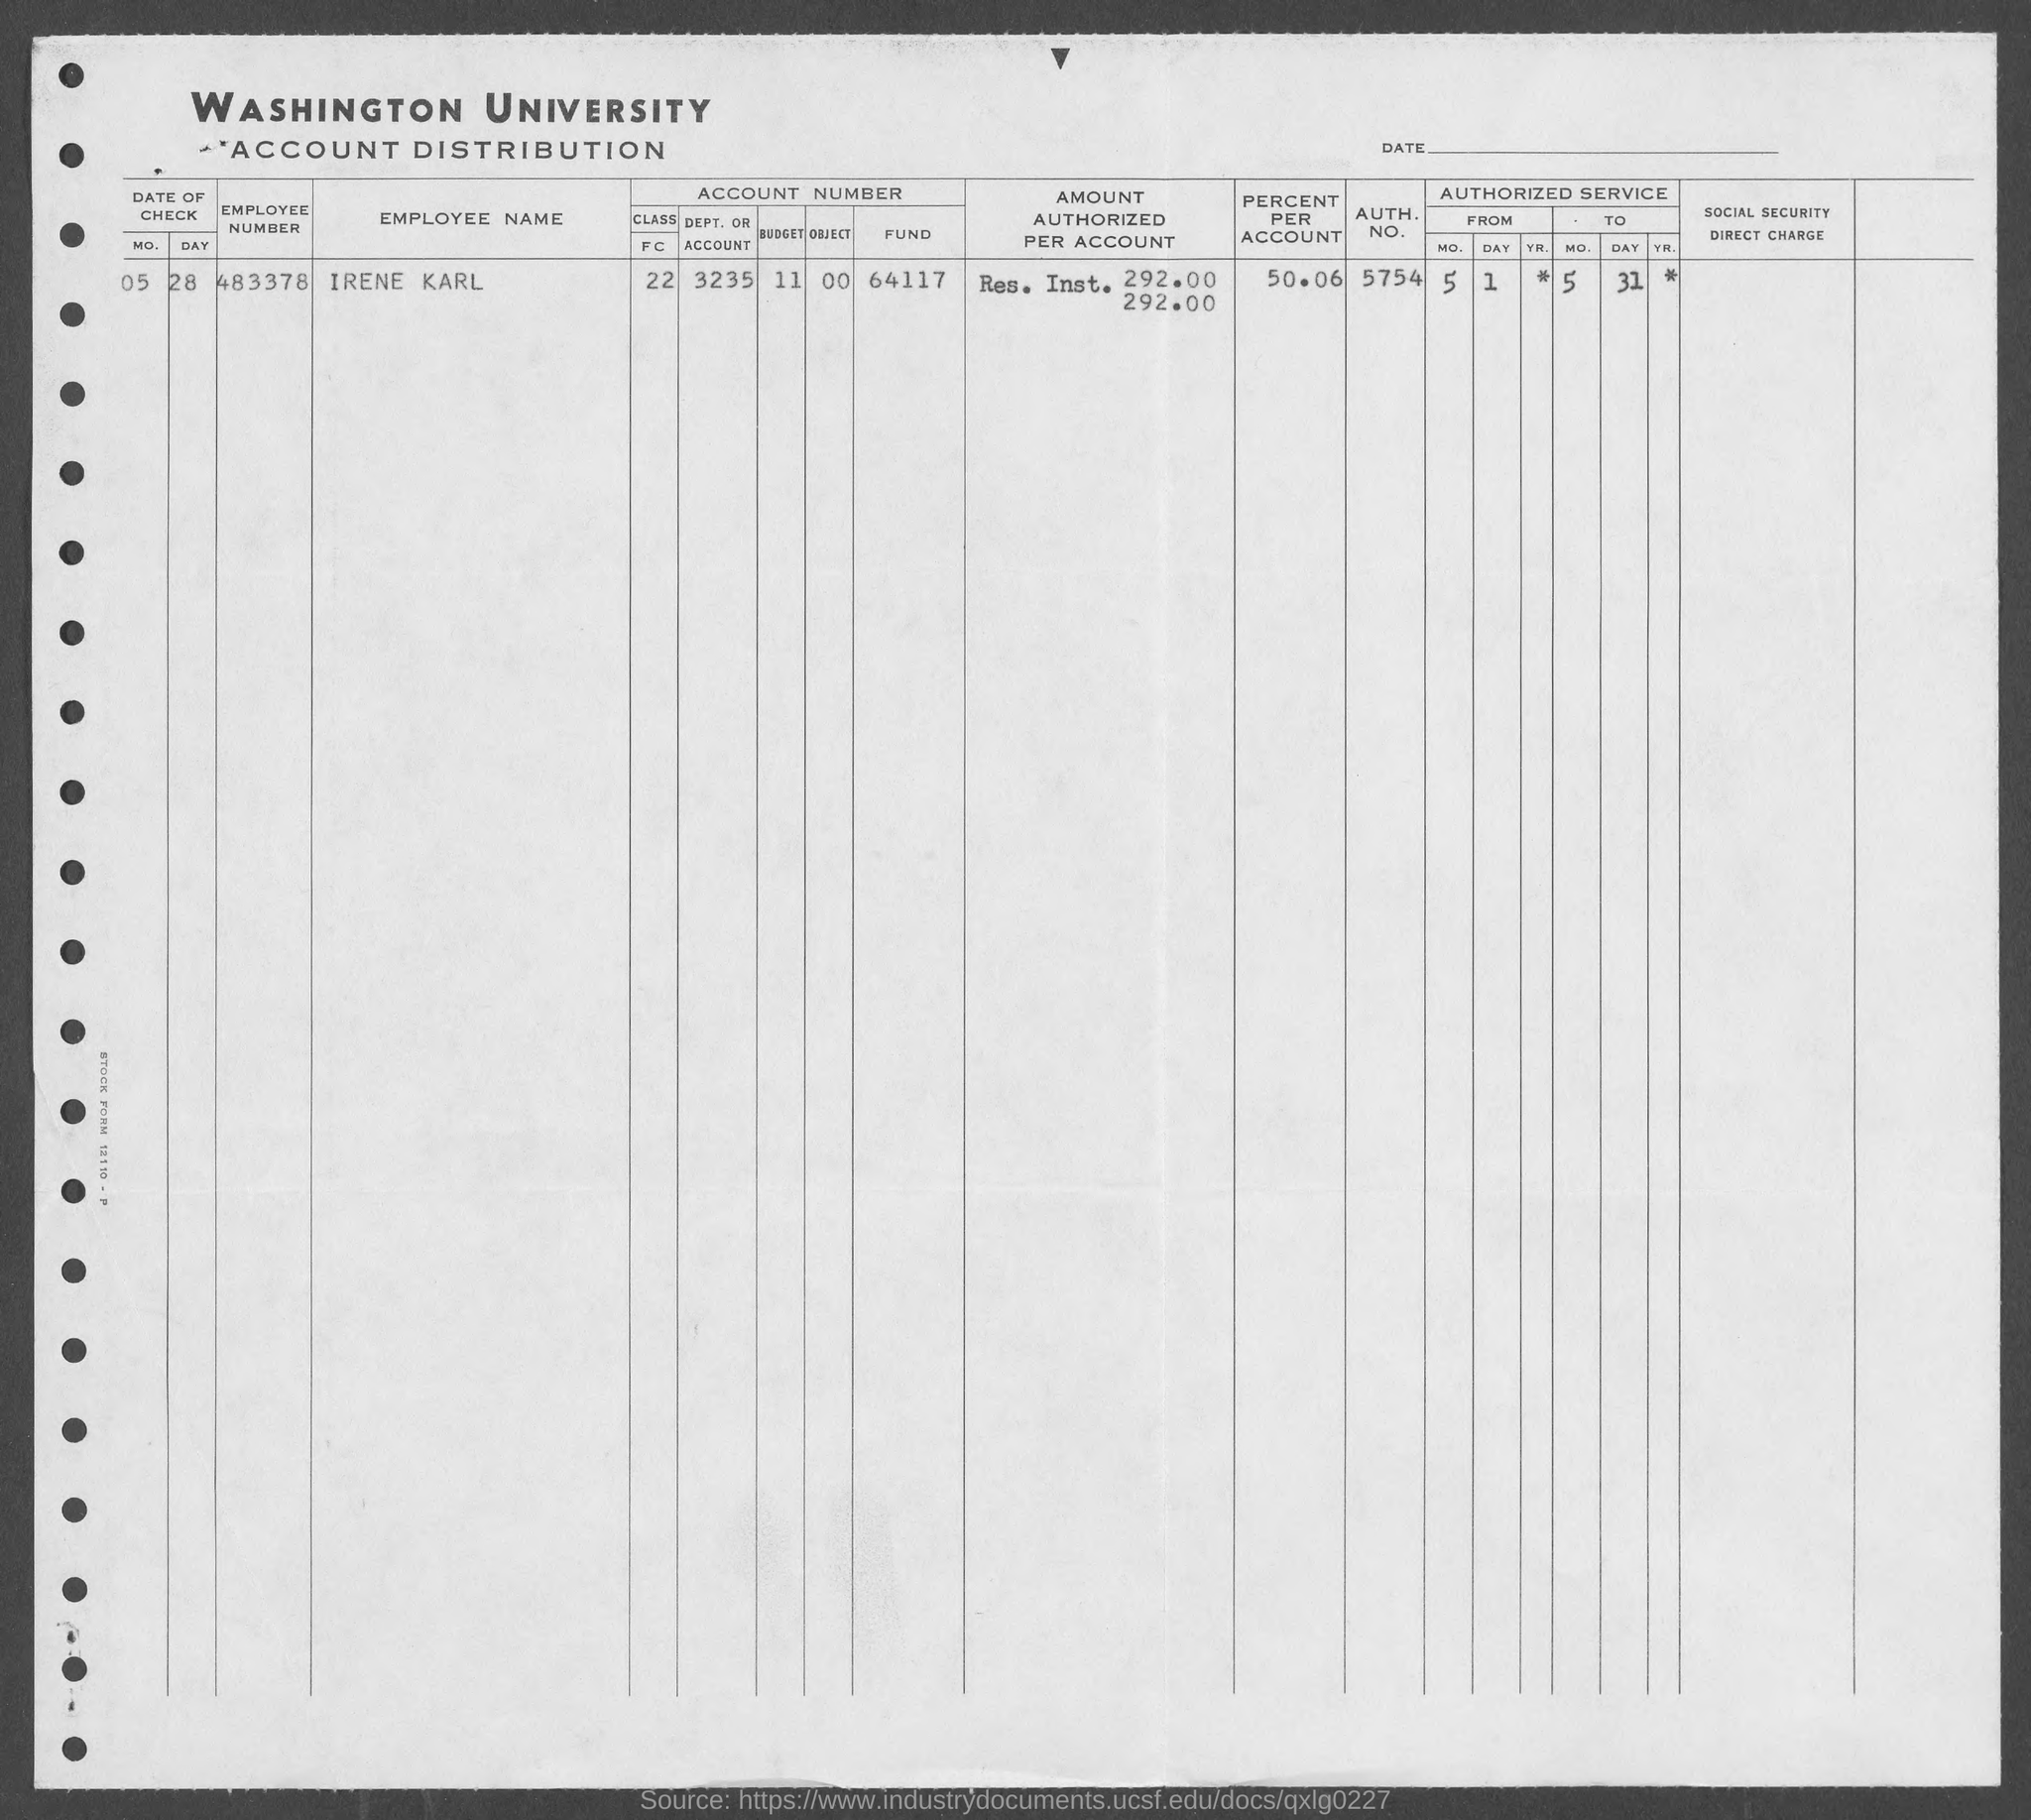Give some essential details in this illustration. Irene Karl's percent is 50.06%. Irene Karl's employee number is 483378... 